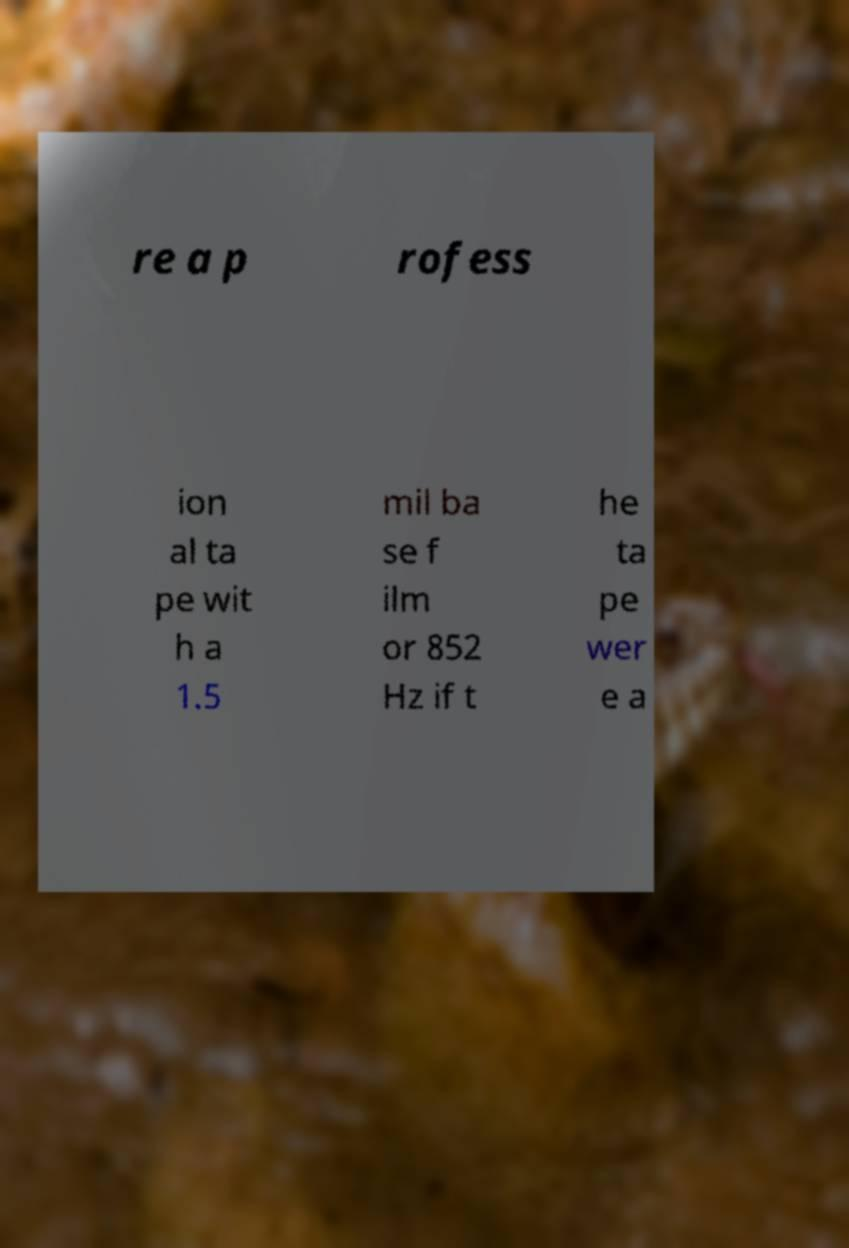I need the written content from this picture converted into text. Can you do that? re a p rofess ion al ta pe wit h a 1.5 mil ba se f ilm or 852 Hz if t he ta pe wer e a 